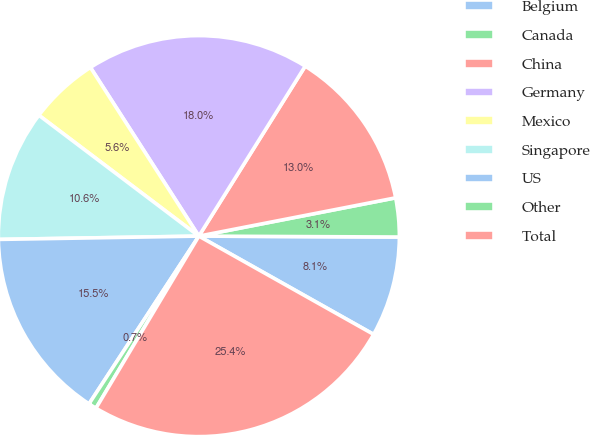Convert chart to OTSL. <chart><loc_0><loc_0><loc_500><loc_500><pie_chart><fcel>Belgium<fcel>Canada<fcel>China<fcel>Germany<fcel>Mexico<fcel>Singapore<fcel>US<fcel>Other<fcel>Total<nl><fcel>8.08%<fcel>3.13%<fcel>13.04%<fcel>17.99%<fcel>5.61%<fcel>10.56%<fcel>15.51%<fcel>0.65%<fcel>25.42%<nl></chart> 